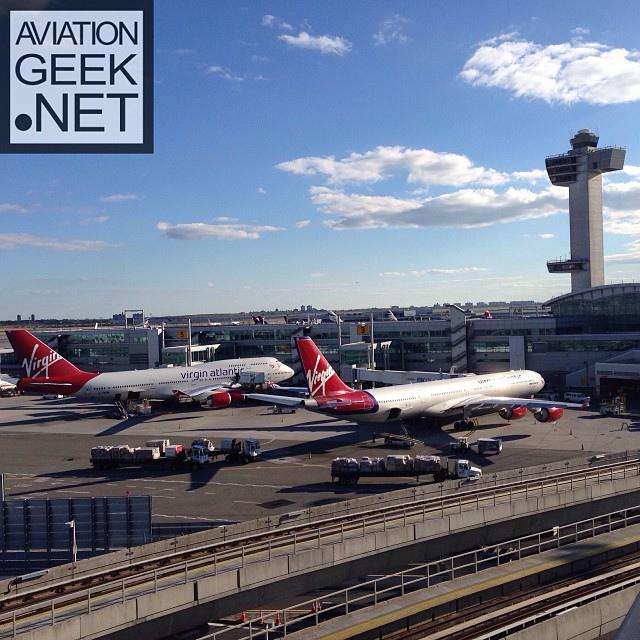How many planes?
Answer briefly. 2. What does the tail of the planes say?
Give a very brief answer. Virgin. What website is shown?
Answer briefly. Aviationgeeknet. What company owns the plane?
Quick response, please. Virgin. 